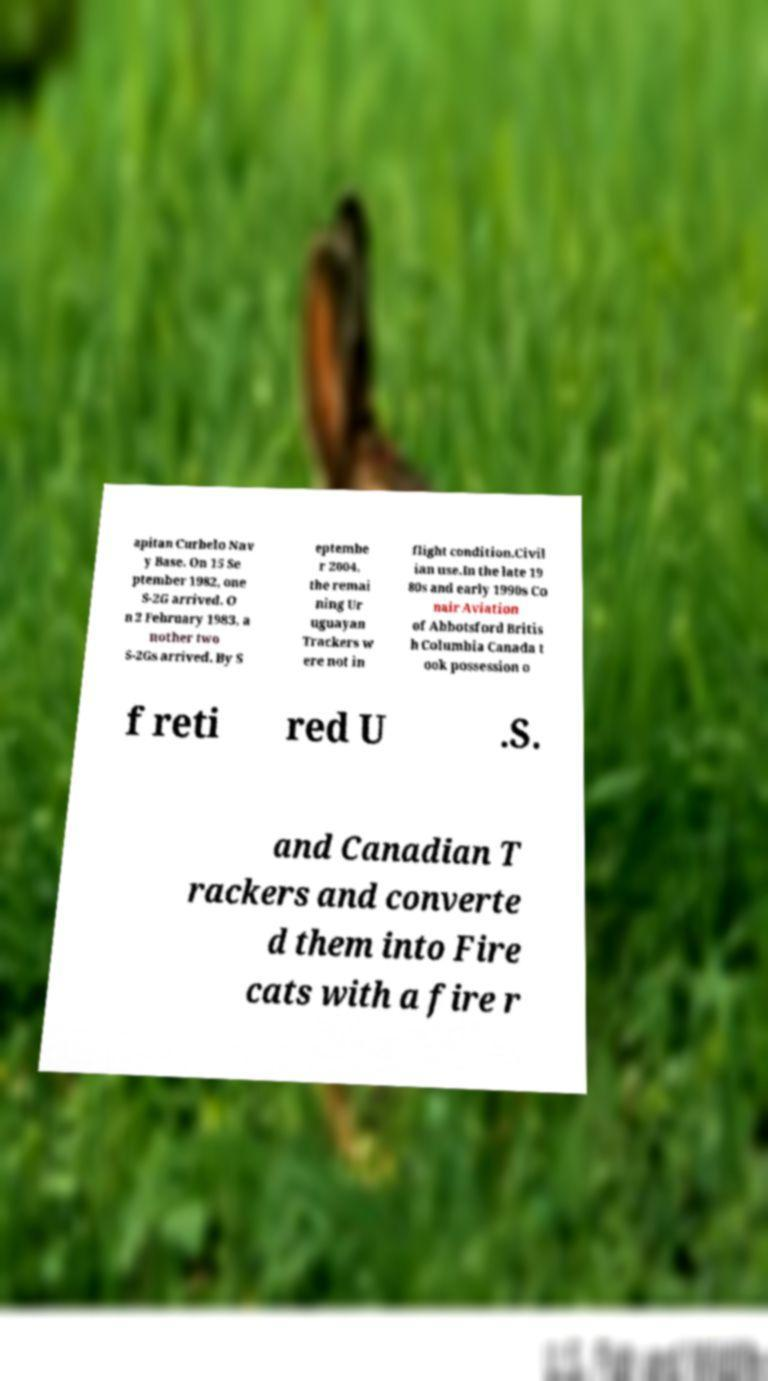Can you accurately transcribe the text from the provided image for me? apitan Curbelo Nav y Base. On 15 Se ptember 1982, one S-2G arrived. O n 2 February 1983, a nother two S-2Gs arrived. By S eptembe r 2004, the remai ning Ur uguayan Trackers w ere not in flight condition.Civil ian use.In the late 19 80s and early 1990s Co nair Aviation of Abbotsford Britis h Columbia Canada t ook possession o f reti red U .S. and Canadian T rackers and converte d them into Fire cats with a fire r 